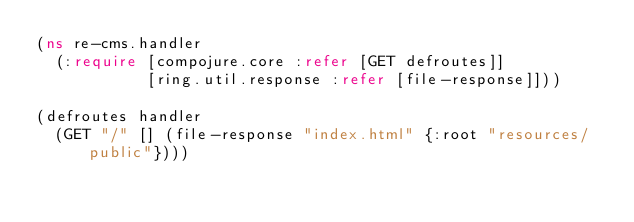<code> <loc_0><loc_0><loc_500><loc_500><_Clojure_>(ns re-cms.handler
  (:require [compojure.core :refer [GET defroutes]]
            [ring.util.response :refer [file-response]]))

(defroutes handler
  (GET "/" [] (file-response "index.html" {:root "resources/public"})))
</code> 